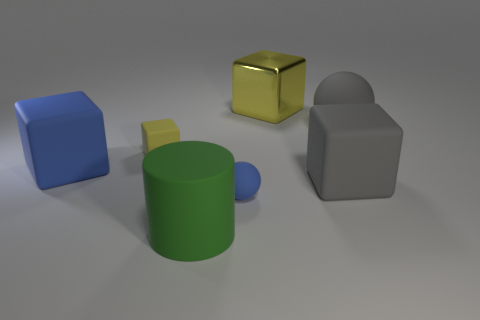Do the small matte block and the big shiny thing have the same color?
Keep it short and to the point. Yes. Is there anything else that is made of the same material as the big yellow thing?
Ensure brevity in your answer.  No. There is a yellow cube in front of the large cube that is behind the big sphere; what is it made of?
Give a very brief answer. Rubber. There is a matte block that is to the right of the small rubber object in front of the blue thing that is left of the green object; how big is it?
Your answer should be compact. Large. What number of other objects are the same shape as the green object?
Your response must be concise. 0. Is the color of the big thing behind the gray ball the same as the tiny thing that is on the left side of the large cylinder?
Your answer should be compact. Yes. What is the color of the ball that is the same size as the green object?
Ensure brevity in your answer.  Gray. Are there any things that have the same color as the small rubber ball?
Your answer should be very brief. Yes. Do the rubber sphere that is in front of the blue block and the tiny yellow matte cube have the same size?
Your answer should be very brief. Yes. Is the number of small matte things in front of the large green thing the same as the number of tiny gray things?
Provide a short and direct response. Yes. 